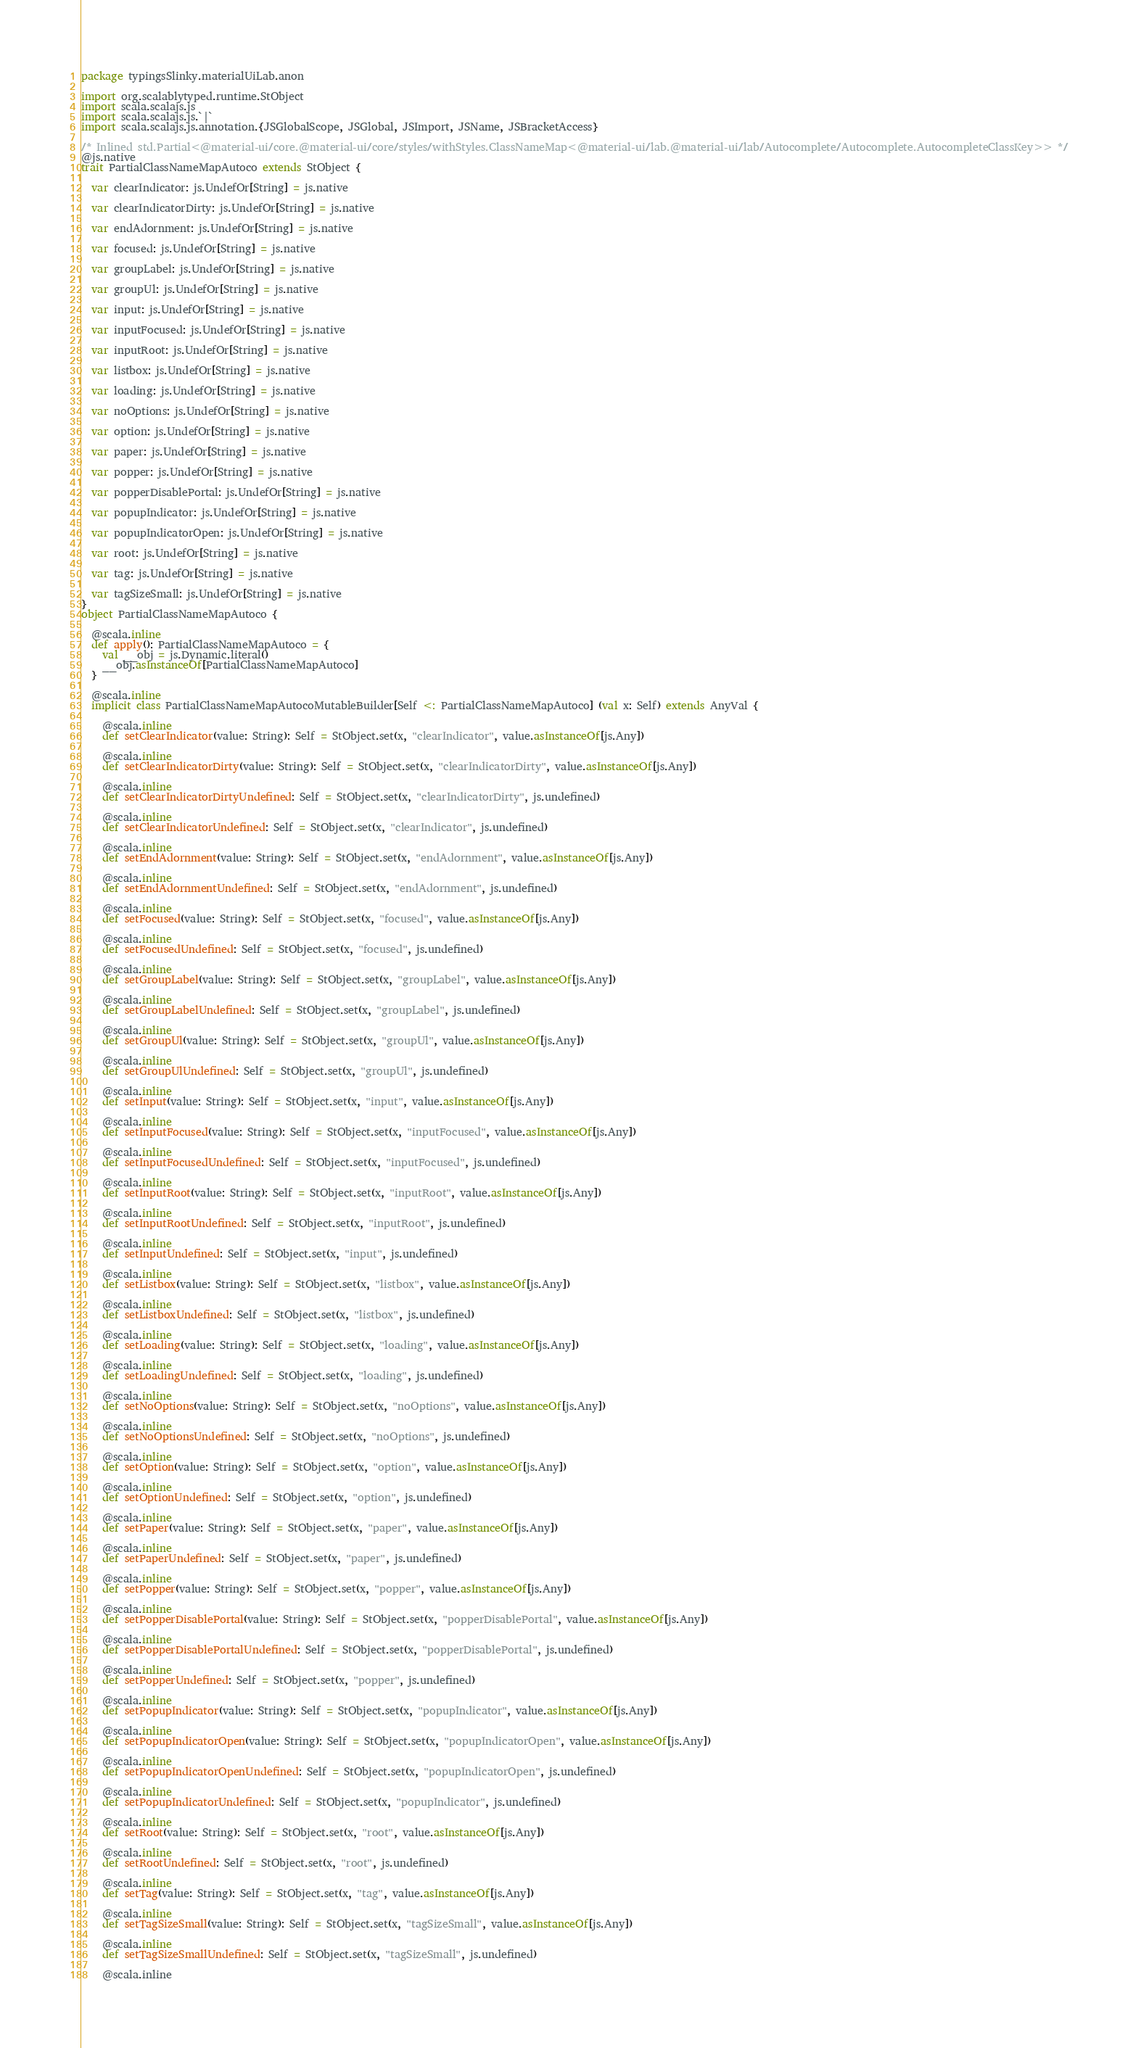<code> <loc_0><loc_0><loc_500><loc_500><_Scala_>package typingsSlinky.materialUiLab.anon

import org.scalablytyped.runtime.StObject
import scala.scalajs.js
import scala.scalajs.js.`|`
import scala.scalajs.js.annotation.{JSGlobalScope, JSGlobal, JSImport, JSName, JSBracketAccess}

/* Inlined std.Partial<@material-ui/core.@material-ui/core/styles/withStyles.ClassNameMap<@material-ui/lab.@material-ui/lab/Autocomplete/Autocomplete.AutocompleteClassKey>> */
@js.native
trait PartialClassNameMapAutoco extends StObject {
  
  var clearIndicator: js.UndefOr[String] = js.native
  
  var clearIndicatorDirty: js.UndefOr[String] = js.native
  
  var endAdornment: js.UndefOr[String] = js.native
  
  var focused: js.UndefOr[String] = js.native
  
  var groupLabel: js.UndefOr[String] = js.native
  
  var groupUl: js.UndefOr[String] = js.native
  
  var input: js.UndefOr[String] = js.native
  
  var inputFocused: js.UndefOr[String] = js.native
  
  var inputRoot: js.UndefOr[String] = js.native
  
  var listbox: js.UndefOr[String] = js.native
  
  var loading: js.UndefOr[String] = js.native
  
  var noOptions: js.UndefOr[String] = js.native
  
  var option: js.UndefOr[String] = js.native
  
  var paper: js.UndefOr[String] = js.native
  
  var popper: js.UndefOr[String] = js.native
  
  var popperDisablePortal: js.UndefOr[String] = js.native
  
  var popupIndicator: js.UndefOr[String] = js.native
  
  var popupIndicatorOpen: js.UndefOr[String] = js.native
  
  var root: js.UndefOr[String] = js.native
  
  var tag: js.UndefOr[String] = js.native
  
  var tagSizeSmall: js.UndefOr[String] = js.native
}
object PartialClassNameMapAutoco {
  
  @scala.inline
  def apply(): PartialClassNameMapAutoco = {
    val __obj = js.Dynamic.literal()
    __obj.asInstanceOf[PartialClassNameMapAutoco]
  }
  
  @scala.inline
  implicit class PartialClassNameMapAutocoMutableBuilder[Self <: PartialClassNameMapAutoco] (val x: Self) extends AnyVal {
    
    @scala.inline
    def setClearIndicator(value: String): Self = StObject.set(x, "clearIndicator", value.asInstanceOf[js.Any])
    
    @scala.inline
    def setClearIndicatorDirty(value: String): Self = StObject.set(x, "clearIndicatorDirty", value.asInstanceOf[js.Any])
    
    @scala.inline
    def setClearIndicatorDirtyUndefined: Self = StObject.set(x, "clearIndicatorDirty", js.undefined)
    
    @scala.inline
    def setClearIndicatorUndefined: Self = StObject.set(x, "clearIndicator", js.undefined)
    
    @scala.inline
    def setEndAdornment(value: String): Self = StObject.set(x, "endAdornment", value.asInstanceOf[js.Any])
    
    @scala.inline
    def setEndAdornmentUndefined: Self = StObject.set(x, "endAdornment", js.undefined)
    
    @scala.inline
    def setFocused(value: String): Self = StObject.set(x, "focused", value.asInstanceOf[js.Any])
    
    @scala.inline
    def setFocusedUndefined: Self = StObject.set(x, "focused", js.undefined)
    
    @scala.inline
    def setGroupLabel(value: String): Self = StObject.set(x, "groupLabel", value.asInstanceOf[js.Any])
    
    @scala.inline
    def setGroupLabelUndefined: Self = StObject.set(x, "groupLabel", js.undefined)
    
    @scala.inline
    def setGroupUl(value: String): Self = StObject.set(x, "groupUl", value.asInstanceOf[js.Any])
    
    @scala.inline
    def setGroupUlUndefined: Self = StObject.set(x, "groupUl", js.undefined)
    
    @scala.inline
    def setInput(value: String): Self = StObject.set(x, "input", value.asInstanceOf[js.Any])
    
    @scala.inline
    def setInputFocused(value: String): Self = StObject.set(x, "inputFocused", value.asInstanceOf[js.Any])
    
    @scala.inline
    def setInputFocusedUndefined: Self = StObject.set(x, "inputFocused", js.undefined)
    
    @scala.inline
    def setInputRoot(value: String): Self = StObject.set(x, "inputRoot", value.asInstanceOf[js.Any])
    
    @scala.inline
    def setInputRootUndefined: Self = StObject.set(x, "inputRoot", js.undefined)
    
    @scala.inline
    def setInputUndefined: Self = StObject.set(x, "input", js.undefined)
    
    @scala.inline
    def setListbox(value: String): Self = StObject.set(x, "listbox", value.asInstanceOf[js.Any])
    
    @scala.inline
    def setListboxUndefined: Self = StObject.set(x, "listbox", js.undefined)
    
    @scala.inline
    def setLoading(value: String): Self = StObject.set(x, "loading", value.asInstanceOf[js.Any])
    
    @scala.inline
    def setLoadingUndefined: Self = StObject.set(x, "loading", js.undefined)
    
    @scala.inline
    def setNoOptions(value: String): Self = StObject.set(x, "noOptions", value.asInstanceOf[js.Any])
    
    @scala.inline
    def setNoOptionsUndefined: Self = StObject.set(x, "noOptions", js.undefined)
    
    @scala.inline
    def setOption(value: String): Self = StObject.set(x, "option", value.asInstanceOf[js.Any])
    
    @scala.inline
    def setOptionUndefined: Self = StObject.set(x, "option", js.undefined)
    
    @scala.inline
    def setPaper(value: String): Self = StObject.set(x, "paper", value.asInstanceOf[js.Any])
    
    @scala.inline
    def setPaperUndefined: Self = StObject.set(x, "paper", js.undefined)
    
    @scala.inline
    def setPopper(value: String): Self = StObject.set(x, "popper", value.asInstanceOf[js.Any])
    
    @scala.inline
    def setPopperDisablePortal(value: String): Self = StObject.set(x, "popperDisablePortal", value.asInstanceOf[js.Any])
    
    @scala.inline
    def setPopperDisablePortalUndefined: Self = StObject.set(x, "popperDisablePortal", js.undefined)
    
    @scala.inline
    def setPopperUndefined: Self = StObject.set(x, "popper", js.undefined)
    
    @scala.inline
    def setPopupIndicator(value: String): Self = StObject.set(x, "popupIndicator", value.asInstanceOf[js.Any])
    
    @scala.inline
    def setPopupIndicatorOpen(value: String): Self = StObject.set(x, "popupIndicatorOpen", value.asInstanceOf[js.Any])
    
    @scala.inline
    def setPopupIndicatorOpenUndefined: Self = StObject.set(x, "popupIndicatorOpen", js.undefined)
    
    @scala.inline
    def setPopupIndicatorUndefined: Self = StObject.set(x, "popupIndicator", js.undefined)
    
    @scala.inline
    def setRoot(value: String): Self = StObject.set(x, "root", value.asInstanceOf[js.Any])
    
    @scala.inline
    def setRootUndefined: Self = StObject.set(x, "root", js.undefined)
    
    @scala.inline
    def setTag(value: String): Self = StObject.set(x, "tag", value.asInstanceOf[js.Any])
    
    @scala.inline
    def setTagSizeSmall(value: String): Self = StObject.set(x, "tagSizeSmall", value.asInstanceOf[js.Any])
    
    @scala.inline
    def setTagSizeSmallUndefined: Self = StObject.set(x, "tagSizeSmall", js.undefined)
    
    @scala.inline</code> 